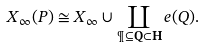<formula> <loc_0><loc_0><loc_500><loc_500>X _ { \infty } ( P ) \cong X _ { \infty } \cup \coprod _ { \P \subseteq \mathbf Q \subset \mathbf H } e ( Q ) .</formula> 